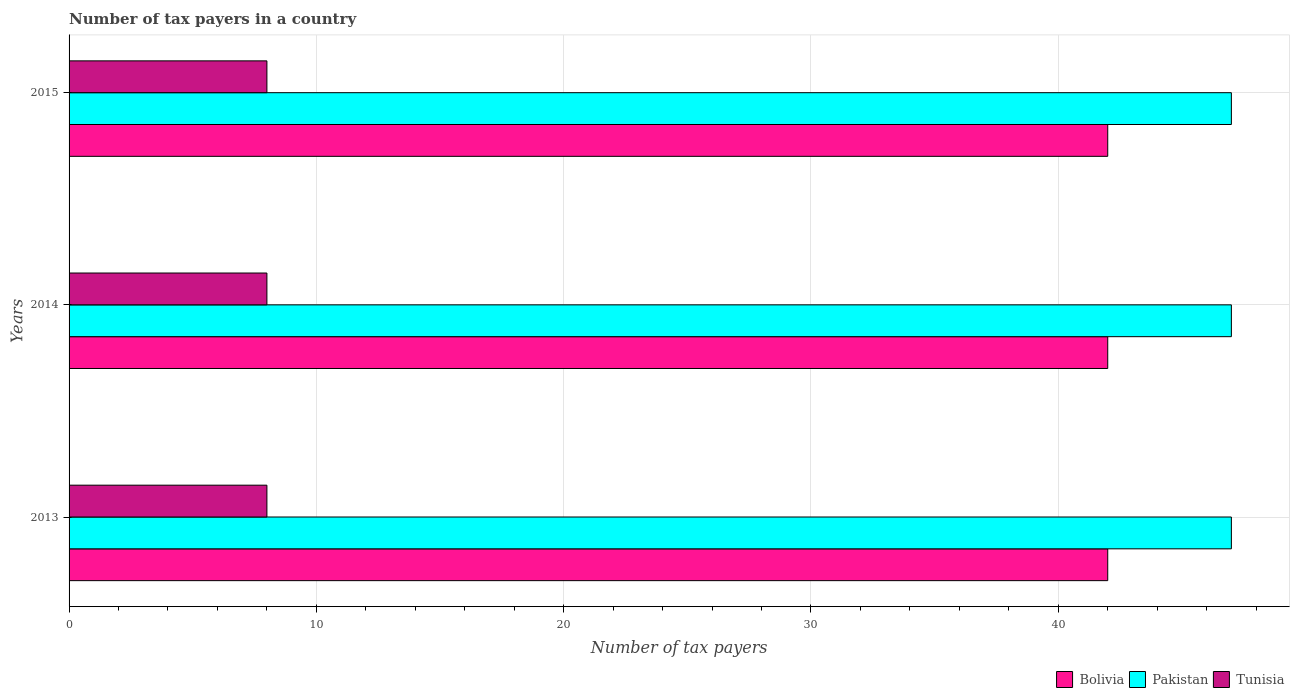Are the number of bars on each tick of the Y-axis equal?
Make the answer very short. Yes. How many bars are there on the 1st tick from the bottom?
Ensure brevity in your answer.  3. What is the label of the 2nd group of bars from the top?
Your answer should be compact. 2014. What is the number of tax payers in in Pakistan in 2013?
Your answer should be compact. 47. In which year was the number of tax payers in in Tunisia maximum?
Give a very brief answer. 2013. In which year was the number of tax payers in in Pakistan minimum?
Provide a succinct answer. 2013. What is the total number of tax payers in in Bolivia in the graph?
Make the answer very short. 126. What is the difference between the number of tax payers in in Tunisia in 2013 and that in 2015?
Your response must be concise. 0. What is the difference between the number of tax payers in in Pakistan in 2013 and the number of tax payers in in Tunisia in 2015?
Your response must be concise. 39. In the year 2013, what is the difference between the number of tax payers in in Pakistan and number of tax payers in in Tunisia?
Offer a very short reply. 39. In how many years, is the number of tax payers in in Pakistan greater than 42 ?
Your response must be concise. 3. What is the ratio of the number of tax payers in in Tunisia in 2014 to that in 2015?
Offer a terse response. 1. Is the difference between the number of tax payers in in Pakistan in 2013 and 2014 greater than the difference between the number of tax payers in in Tunisia in 2013 and 2014?
Provide a succinct answer. No. What is the difference between the highest and the lowest number of tax payers in in Bolivia?
Give a very brief answer. 0. In how many years, is the number of tax payers in in Bolivia greater than the average number of tax payers in in Bolivia taken over all years?
Keep it short and to the point. 0. Is the sum of the number of tax payers in in Bolivia in 2013 and 2015 greater than the maximum number of tax payers in in Tunisia across all years?
Your answer should be compact. Yes. What does the 1st bar from the top in 2013 represents?
Your response must be concise. Tunisia. Is it the case that in every year, the sum of the number of tax payers in in Bolivia and number of tax payers in in Pakistan is greater than the number of tax payers in in Tunisia?
Ensure brevity in your answer.  Yes. How many bars are there?
Make the answer very short. 9. How many years are there in the graph?
Your answer should be very brief. 3. How many legend labels are there?
Provide a succinct answer. 3. What is the title of the graph?
Your answer should be very brief. Number of tax payers in a country. Does "Mozambique" appear as one of the legend labels in the graph?
Your response must be concise. No. What is the label or title of the X-axis?
Your answer should be compact. Number of tax payers. What is the label or title of the Y-axis?
Provide a short and direct response. Years. What is the Number of tax payers of Pakistan in 2013?
Offer a terse response. 47. What is the Number of tax payers in Bolivia in 2014?
Keep it short and to the point. 42. What is the Number of tax payers of Tunisia in 2014?
Offer a very short reply. 8. What is the Number of tax payers in Bolivia in 2015?
Your answer should be very brief. 42. What is the Number of tax payers of Tunisia in 2015?
Give a very brief answer. 8. Across all years, what is the minimum Number of tax payers in Bolivia?
Provide a succinct answer. 42. Across all years, what is the minimum Number of tax payers of Pakistan?
Offer a very short reply. 47. What is the total Number of tax payers of Bolivia in the graph?
Give a very brief answer. 126. What is the total Number of tax payers of Pakistan in the graph?
Offer a terse response. 141. What is the total Number of tax payers of Tunisia in the graph?
Ensure brevity in your answer.  24. What is the difference between the Number of tax payers in Bolivia in 2013 and that in 2014?
Provide a succinct answer. 0. What is the difference between the Number of tax payers of Pakistan in 2013 and that in 2014?
Your answer should be compact. 0. What is the difference between the Number of tax payers in Tunisia in 2013 and that in 2014?
Offer a very short reply. 0. What is the difference between the Number of tax payers of Pakistan in 2013 and that in 2015?
Your answer should be very brief. 0. What is the difference between the Number of tax payers of Bolivia in 2014 and that in 2015?
Offer a very short reply. 0. What is the difference between the Number of tax payers in Bolivia in 2013 and the Number of tax payers in Pakistan in 2014?
Offer a very short reply. -5. What is the difference between the Number of tax payers of Bolivia in 2013 and the Number of tax payers of Tunisia in 2014?
Keep it short and to the point. 34. What is the difference between the Number of tax payers in Pakistan in 2013 and the Number of tax payers in Tunisia in 2014?
Make the answer very short. 39. What is the difference between the Number of tax payers of Bolivia in 2013 and the Number of tax payers of Tunisia in 2015?
Offer a very short reply. 34. What is the difference between the Number of tax payers of Pakistan in 2013 and the Number of tax payers of Tunisia in 2015?
Your answer should be compact. 39. What is the difference between the Number of tax payers of Pakistan in 2014 and the Number of tax payers of Tunisia in 2015?
Give a very brief answer. 39. What is the average Number of tax payers in Pakistan per year?
Ensure brevity in your answer.  47. In the year 2013, what is the difference between the Number of tax payers of Bolivia and Number of tax payers of Pakistan?
Your answer should be compact. -5. In the year 2013, what is the difference between the Number of tax payers of Pakistan and Number of tax payers of Tunisia?
Your answer should be very brief. 39. In the year 2014, what is the difference between the Number of tax payers in Bolivia and Number of tax payers in Pakistan?
Your answer should be compact. -5. In the year 2015, what is the difference between the Number of tax payers of Bolivia and Number of tax payers of Pakistan?
Offer a terse response. -5. What is the ratio of the Number of tax payers of Bolivia in 2013 to that in 2014?
Provide a succinct answer. 1. What is the ratio of the Number of tax payers of Pakistan in 2013 to that in 2014?
Offer a terse response. 1. What is the ratio of the Number of tax payers of Tunisia in 2013 to that in 2014?
Keep it short and to the point. 1. What is the ratio of the Number of tax payers of Bolivia in 2013 to that in 2015?
Your answer should be very brief. 1. What is the ratio of the Number of tax payers in Tunisia in 2013 to that in 2015?
Keep it short and to the point. 1. What is the ratio of the Number of tax payers in Bolivia in 2014 to that in 2015?
Your answer should be very brief. 1. What is the ratio of the Number of tax payers in Pakistan in 2014 to that in 2015?
Your answer should be very brief. 1. What is the ratio of the Number of tax payers in Tunisia in 2014 to that in 2015?
Your answer should be compact. 1. What is the difference between the highest and the second highest Number of tax payers in Bolivia?
Keep it short and to the point. 0. What is the difference between the highest and the second highest Number of tax payers of Pakistan?
Make the answer very short. 0. What is the difference between the highest and the lowest Number of tax payers in Bolivia?
Provide a succinct answer. 0. What is the difference between the highest and the lowest Number of tax payers in Pakistan?
Keep it short and to the point. 0. What is the difference between the highest and the lowest Number of tax payers in Tunisia?
Offer a terse response. 0. 